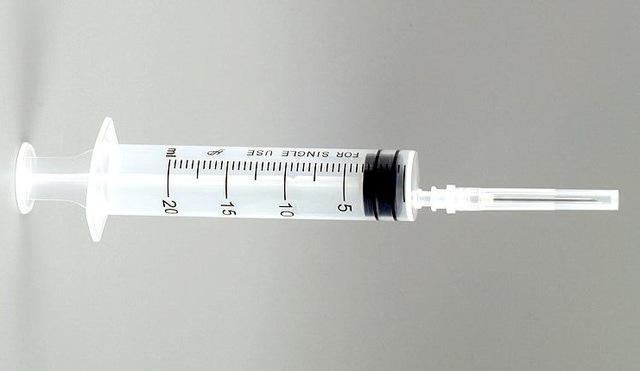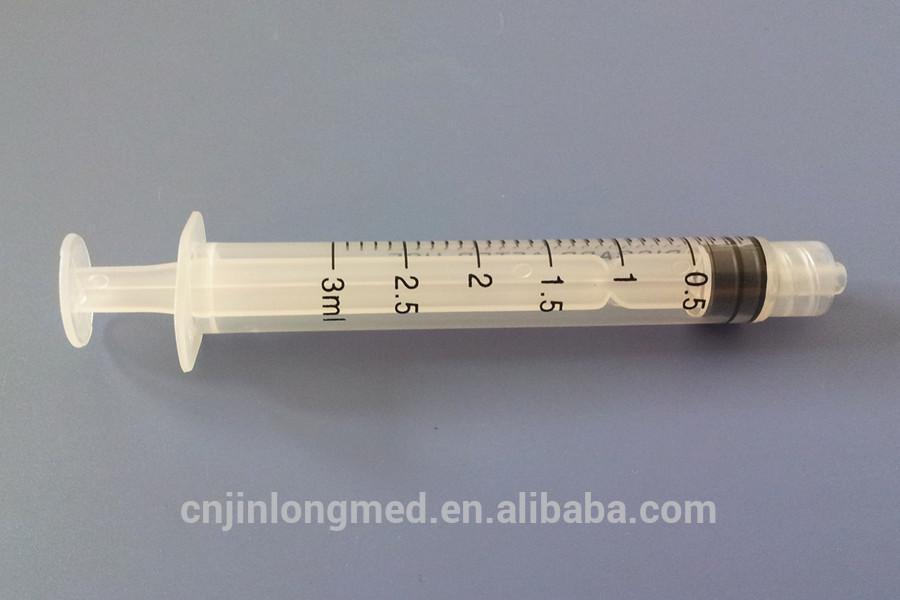The first image is the image on the left, the second image is the image on the right. Examine the images to the left and right. Is the description "There are no more than two syringes." accurate? Answer yes or no. Yes. The first image is the image on the left, the second image is the image on the right. Given the left and right images, does the statement "There is exactly one syringe in the right image." hold true? Answer yes or no. Yes. 